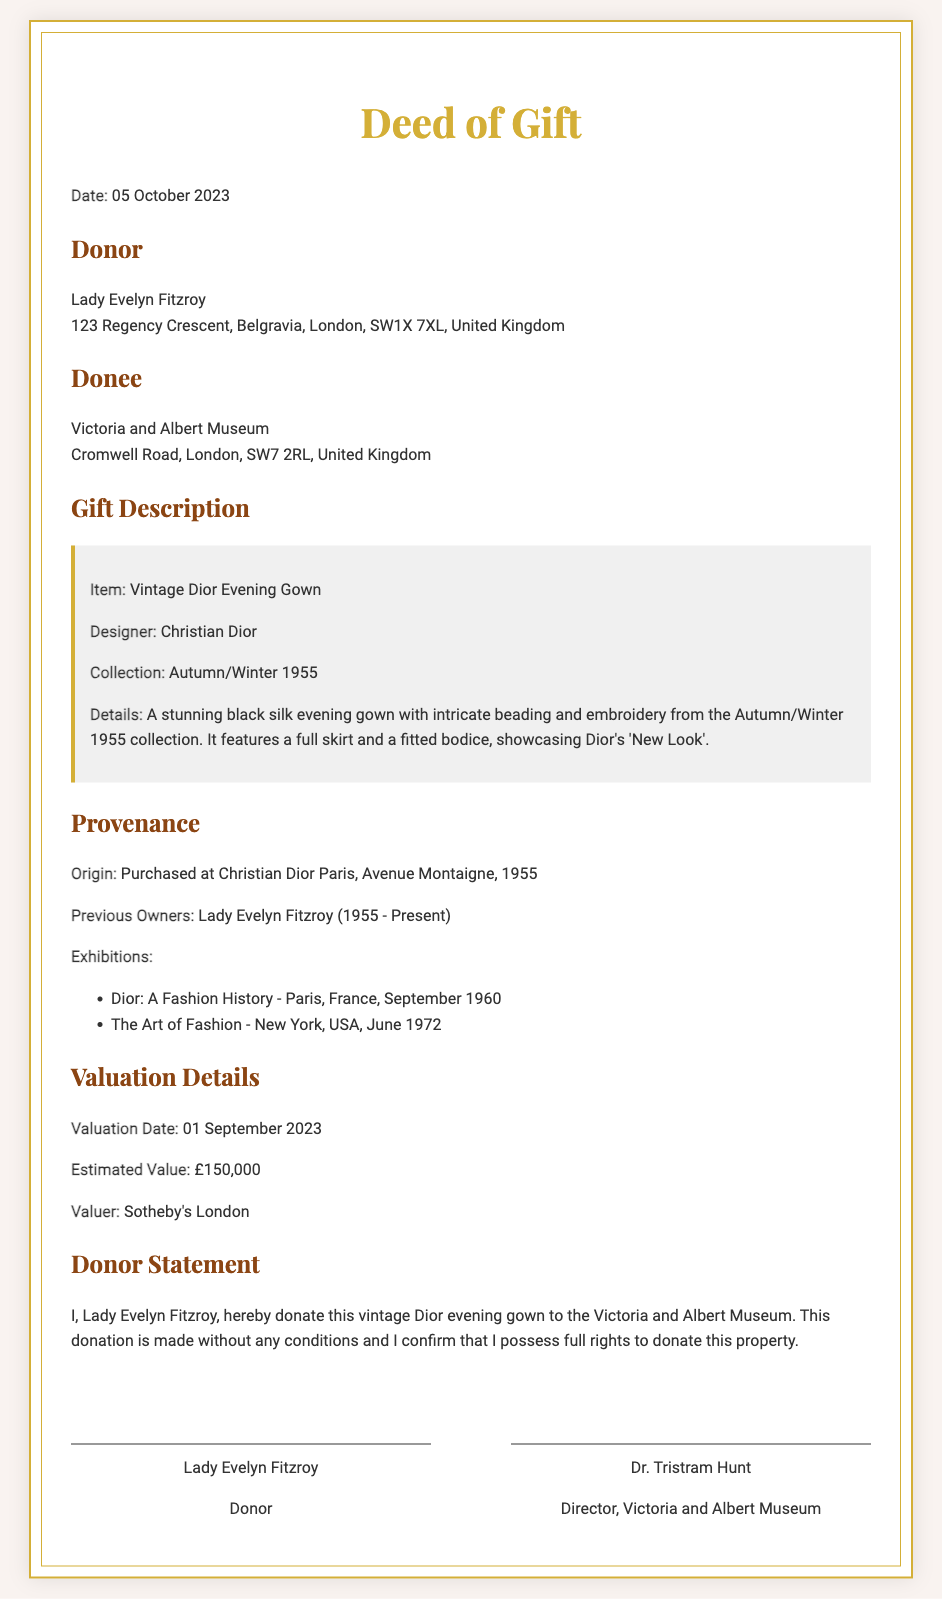What is the date of the deed? The date of the deed is mentioned as "05 October 2023."
Answer: 05 October 2023 Who is the donor? The document states that the donor is "Lady Evelyn Fitzroy."
Answer: Lady Evelyn Fitzroy What is the item being donated? The deed specifies that the item being donated is a "Vintage Dior Evening Gown."
Answer: Vintage Dior Evening Gown What is the estimated value? The estimated value provided in the document is "£150,000."
Answer: £150,000 What collection is the gown from? The document indicates that the gown is from the "Autumn/Winter 1955" collection.
Answer: Autumn/Winter 1955 What is the origin of the gown? The origin of the gown is noted as "Purchased at Christian Dior Paris, Avenue Montaigne, 1955."
Answer: Purchased at Christian Dior Paris, Avenue Montaigne, 1955 How many previous owners are listed? The document mentions one previous owner: "Lady Evelyn Fitzroy."
Answer: One Who conducted the valuation? The document states that the valuer is "Sotheby's London."
Answer: Sotheby's London What type of document is this? This document is a "Deed of Gift."
Answer: Deed of Gift 